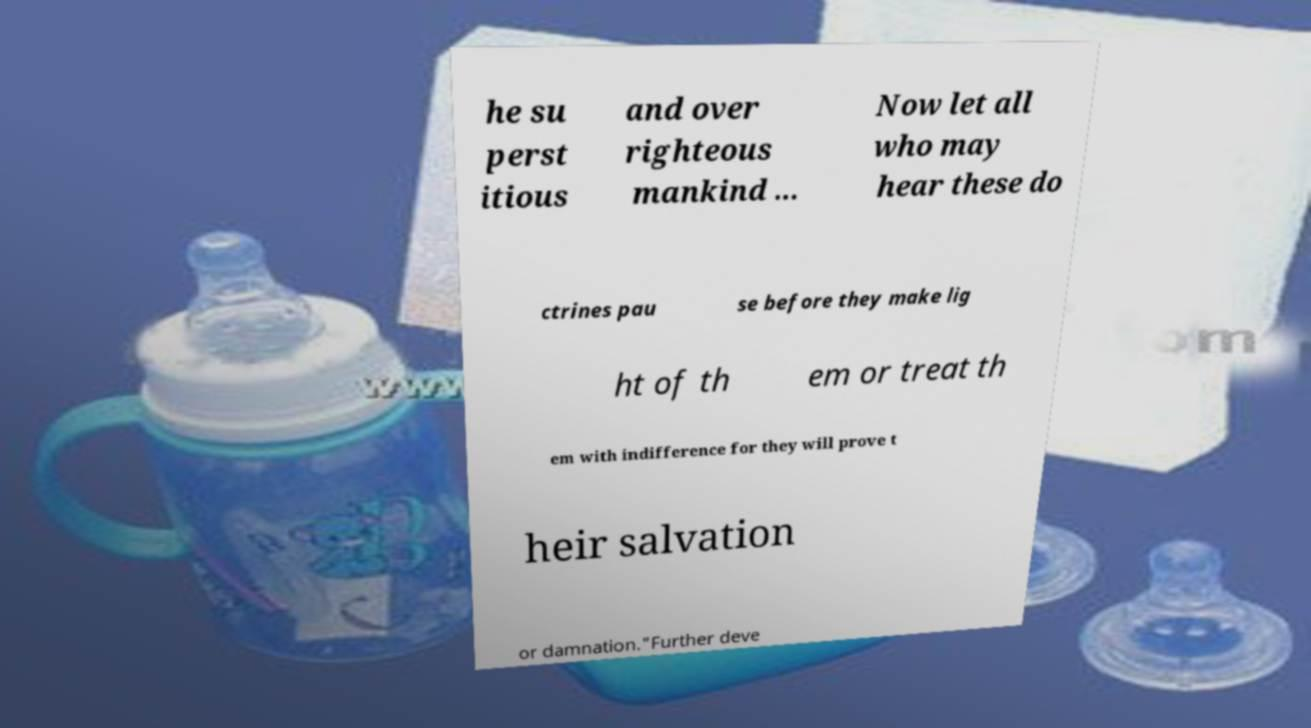For documentation purposes, I need the text within this image transcribed. Could you provide that? he su perst itious and over righteous mankind ... Now let all who may hear these do ctrines pau se before they make lig ht of th em or treat th em with indifference for they will prove t heir salvation or damnation."Further deve 